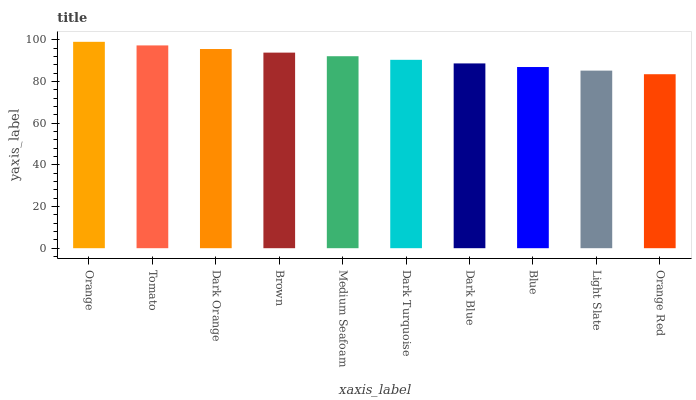Is Orange Red the minimum?
Answer yes or no. Yes. Is Orange the maximum?
Answer yes or no. Yes. Is Tomato the minimum?
Answer yes or no. No. Is Tomato the maximum?
Answer yes or no. No. Is Orange greater than Tomato?
Answer yes or no. Yes. Is Tomato less than Orange?
Answer yes or no. Yes. Is Tomato greater than Orange?
Answer yes or no. No. Is Orange less than Tomato?
Answer yes or no. No. Is Medium Seafoam the high median?
Answer yes or no. Yes. Is Dark Turquoise the low median?
Answer yes or no. Yes. Is Orange the high median?
Answer yes or no. No. Is Tomato the low median?
Answer yes or no. No. 